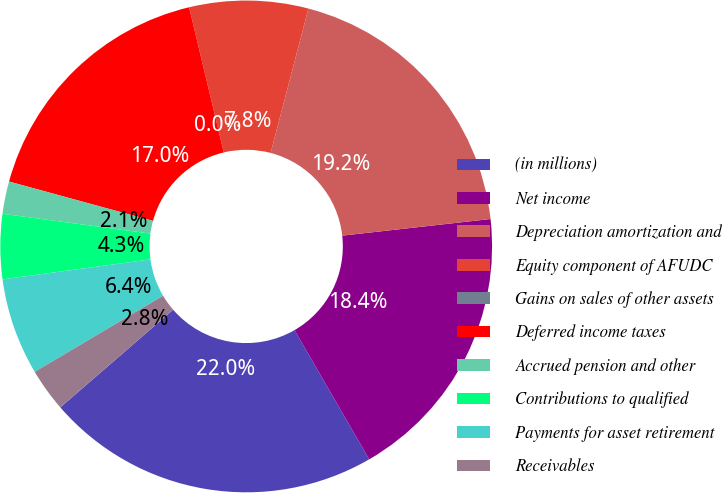Convert chart. <chart><loc_0><loc_0><loc_500><loc_500><pie_chart><fcel>(in millions)<fcel>Net income<fcel>Depreciation amortization and<fcel>Equity component of AFUDC<fcel>Gains on sales of other assets<fcel>Deferred income taxes<fcel>Accrued pension and other<fcel>Contributions to qualified<fcel>Payments for asset retirement<fcel>Receivables<nl><fcel>21.98%<fcel>18.44%<fcel>19.15%<fcel>7.8%<fcel>0.0%<fcel>17.02%<fcel>2.13%<fcel>4.26%<fcel>6.38%<fcel>2.84%<nl></chart> 